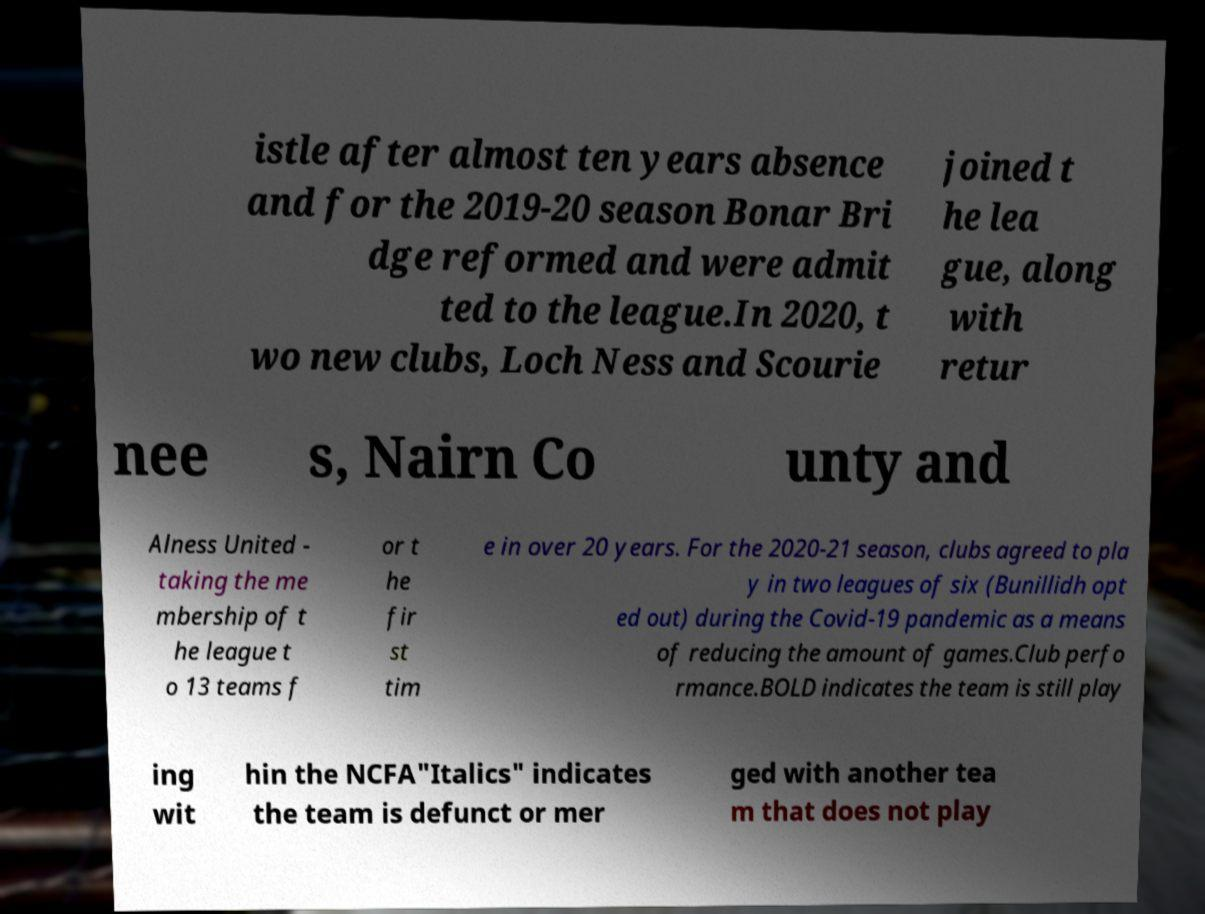I need the written content from this picture converted into text. Can you do that? istle after almost ten years absence and for the 2019-20 season Bonar Bri dge reformed and were admit ted to the league.In 2020, t wo new clubs, Loch Ness and Scourie joined t he lea gue, along with retur nee s, Nairn Co unty and Alness United - taking the me mbership of t he league t o 13 teams f or t he fir st tim e in over 20 years. For the 2020-21 season, clubs agreed to pla y in two leagues of six (Bunillidh opt ed out) during the Covid-19 pandemic as a means of reducing the amount of games.Club perfo rmance.BOLD indicates the team is still play ing wit hin the NCFA"Italics" indicates the team is defunct or mer ged with another tea m that does not play 